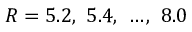Convert formula to latex. <formula><loc_0><loc_0><loc_500><loc_500>R = 5 . 2 , \ 5 . 4 , \ \dots , \ 8 . 0</formula> 